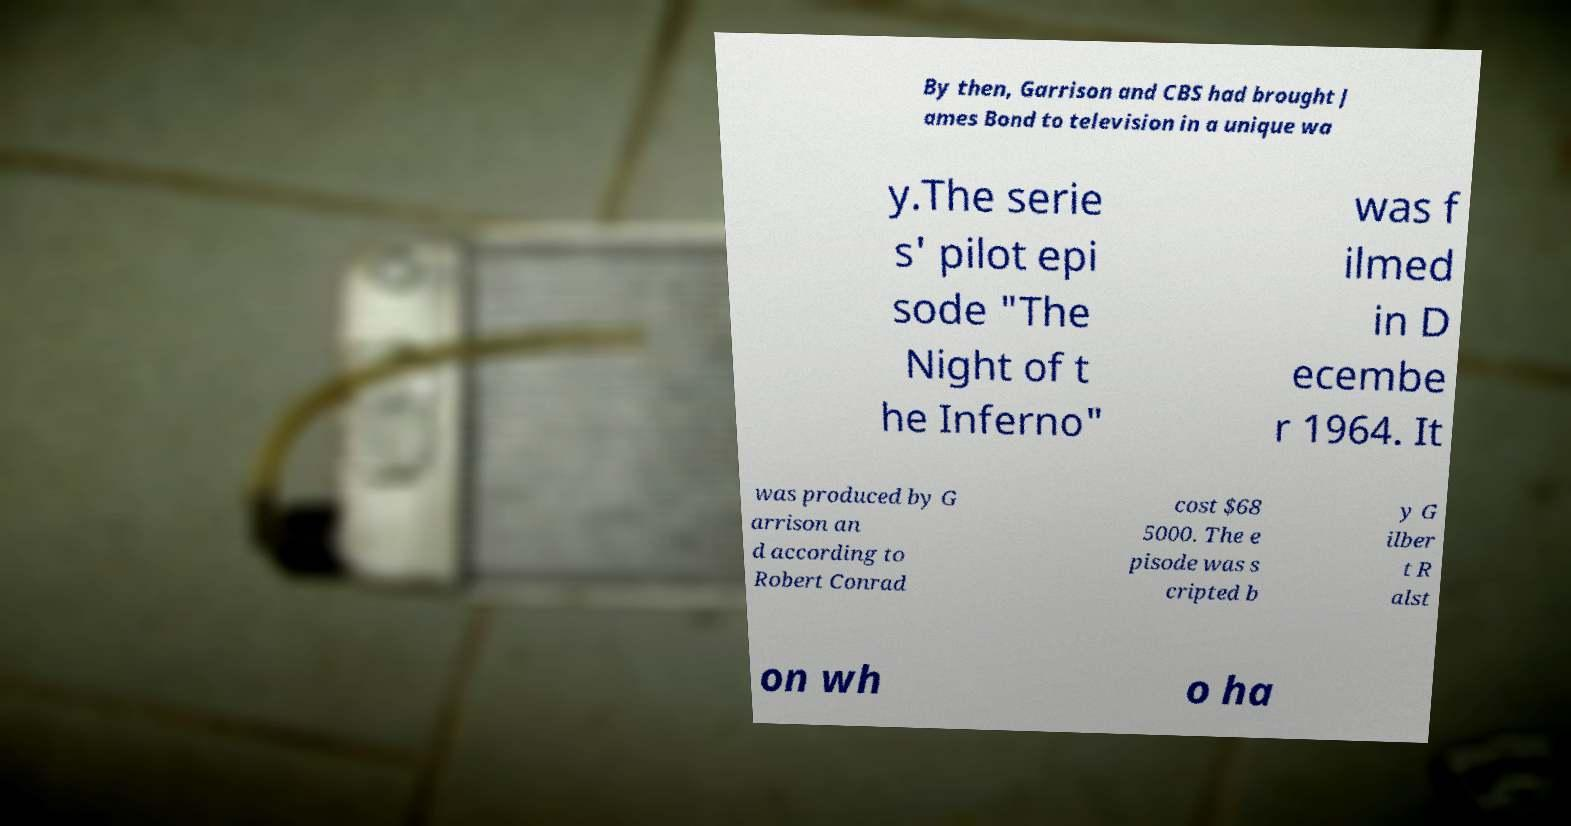There's text embedded in this image that I need extracted. Can you transcribe it verbatim? By then, Garrison and CBS had brought J ames Bond to television in a unique wa y.The serie s' pilot epi sode "The Night of t he Inferno" was f ilmed in D ecembe r 1964. It was produced by G arrison an d according to Robert Conrad cost $68 5000. The e pisode was s cripted b y G ilber t R alst on wh o ha 